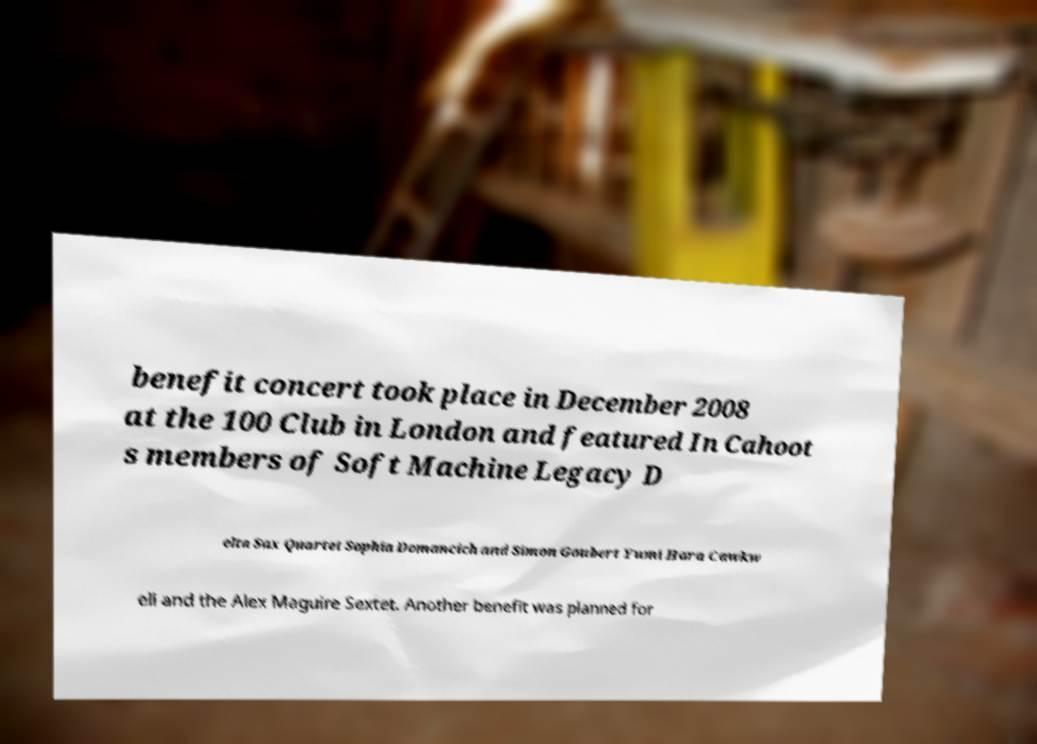Please read and relay the text visible in this image. What does it say? benefit concert took place in December 2008 at the 100 Club in London and featured In Cahoot s members of Soft Machine Legacy D elta Sax Quartet Sophia Domancich and Simon Goubert Yumi Hara Cawkw ell and the Alex Maguire Sextet. Another benefit was planned for 